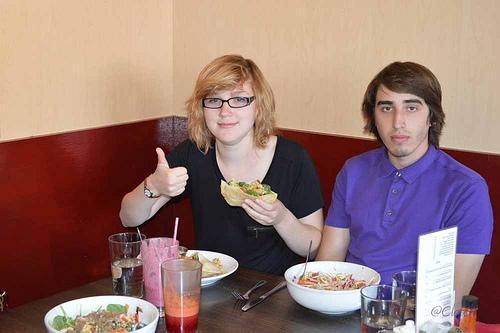How many people are pictured?
Give a very brief answer. 2. How many bowls are visible?
Give a very brief answer. 3. 